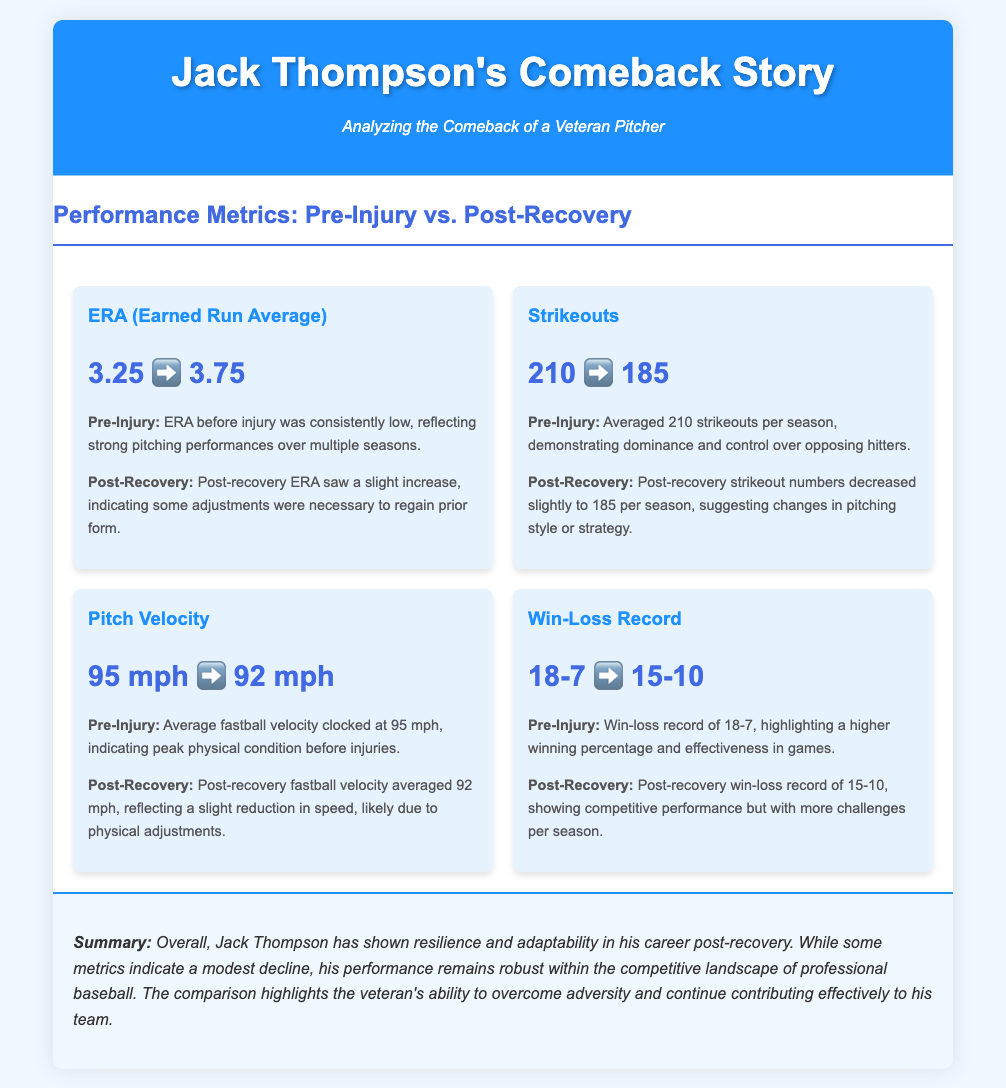What is the pre-injury ERA? The pre-injury ERA is listed in the document as 3.25.
Answer: 3.25 What was the strikeout count post-recovery? The post-recovery strikeout count is recorded as 185 in the document.
Answer: 185 What is the change in pitch velocity after recovery? The document states that the pitch velocity decreased from 95 mph to 92 mph, indicating a reduction of 3 mph.
Answer: 3 mph What does the win-loss record post-recovery reflect? The post-recovery win-loss record shows 15-10 according to the document, indicating competitive performance.
Answer: 15-10 How does the pre-injury win-loss record compare to post-recovery? The document highlights that pre-injury win-loss record was 18-7, indicating a higher winning percentage than the post-recovery record of 15-10.
Answer: 18-7 vs. 15-10 What adjustment is suggested in the post-recovery ERA? The document notes that the post-recovery ERA shows a slight increase, suggesting adjustments were necessary.
Answer: Slight increase How many average strikeouts did he have before his injury? The document states that before the injury, he averaged 210 strikeouts per season.
Answer: 210 What does the summary indicate about Jack Thompson's performance post-recovery? The summary indicates that Jack Thompson's performance remains robust despite modest declines in some metrics post-recovery.
Answer: Robust performance What theme does the infographic emphasize about resilience? The document emphasizes resilience and adaptability in Jack Thompson's career following his injuries.
Answer: Resilience and adaptability 